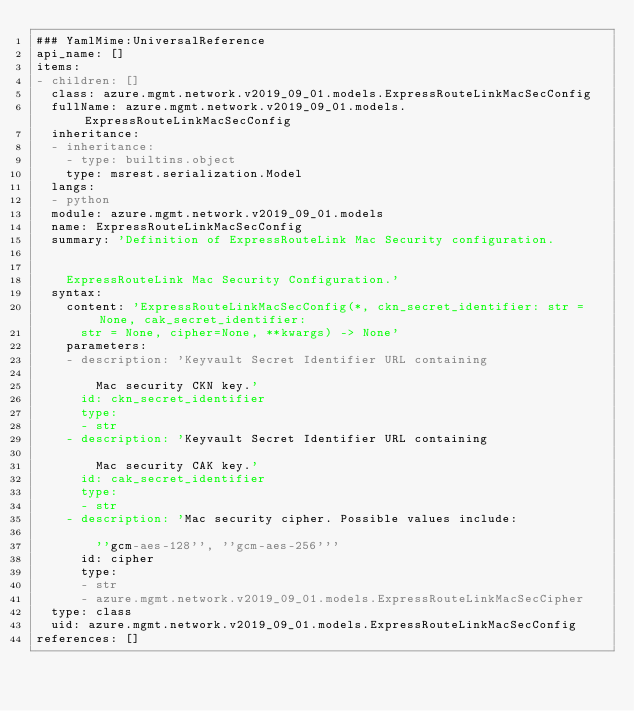Convert code to text. <code><loc_0><loc_0><loc_500><loc_500><_YAML_>### YamlMime:UniversalReference
api_name: []
items:
- children: []
  class: azure.mgmt.network.v2019_09_01.models.ExpressRouteLinkMacSecConfig
  fullName: azure.mgmt.network.v2019_09_01.models.ExpressRouteLinkMacSecConfig
  inheritance:
  - inheritance:
    - type: builtins.object
    type: msrest.serialization.Model
  langs:
  - python
  module: azure.mgmt.network.v2019_09_01.models
  name: ExpressRouteLinkMacSecConfig
  summary: 'Definition of ExpressRouteLink Mac Security configuration.


    ExpressRouteLink Mac Security Configuration.'
  syntax:
    content: 'ExpressRouteLinkMacSecConfig(*, ckn_secret_identifier: str = None, cak_secret_identifier:
      str = None, cipher=None, **kwargs) -> None'
    parameters:
    - description: 'Keyvault Secret Identifier URL containing

        Mac security CKN key.'
      id: ckn_secret_identifier
      type:
      - str
    - description: 'Keyvault Secret Identifier URL containing

        Mac security CAK key.'
      id: cak_secret_identifier
      type:
      - str
    - description: 'Mac security cipher. Possible values include:

        ''gcm-aes-128'', ''gcm-aes-256'''
      id: cipher
      type:
      - str
      - azure.mgmt.network.v2019_09_01.models.ExpressRouteLinkMacSecCipher
  type: class
  uid: azure.mgmt.network.v2019_09_01.models.ExpressRouteLinkMacSecConfig
references: []
</code> 